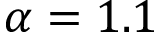Convert formula to latex. <formula><loc_0><loc_0><loc_500><loc_500>\alpha = 1 . 1</formula> 